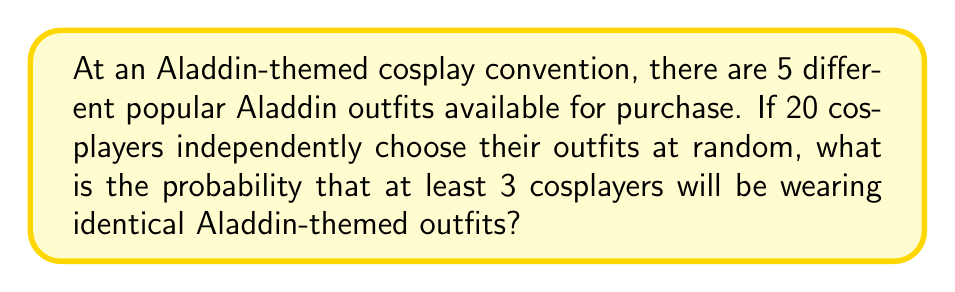Provide a solution to this math problem. Let's approach this step-by-step using the complementary event method:

1) First, we need to find the probability of having at most 2 cosplayers wearing identical outfits.

2) We can use the Multinomial distribution to solve this problem. The probability mass function of the Multinomial distribution is:

   $$P(X_1 = x_1, ..., X_k = x_k) = \frac{n!}{x_1! ... x_k!} p_1^{x_1} ... p_k^{x_k}$$

   where $n$ is the total number of trials, $k$ is the number of categories, $x_i$ is the number of occurrences in category $i$, and $p_i$ is the probability of category $i$.

3) In our case:
   $n = 20$ (total cosplayers)
   $k = 5$ (number of outfit types)
   $p_i = \frac{1}{5}$ for all $i$ (equal probability for each outfit)

4) We need to sum up the probabilities of all configurations where no outfit is worn by more than 2 cosplayers. Let's call this probability $P(\text{at most 2})$.

5) The possible configurations are:
   (2,2,2,2,12), (2,2,2,1,13), (2,2,1,1,14), (2,1,1,1,15), (1,1,1,1,16)
   where each number represents the count of cosplayers wearing each outfit type.

6) For each configuration, we calculate its probability and sum them:

   $$P(\text{at most 2}) = \sum_{\text{config}} \frac{20!}{x_1!x_2!x_3!x_4!x_5!} (\frac{1}{5})^{20}$$

7) After calculating and summing all these probabilities, we get:
   $P(\text{at most 2}) \approx 0.0388$

8) Therefore, the probability of at least 3 cosplayers wearing identical outfits is:
   $P(\text{at least 3}) = 1 - P(\text{at most 2}) \approx 1 - 0.0388 = 0.9612$
Answer: $0.9612$ or $96.12\%$ 